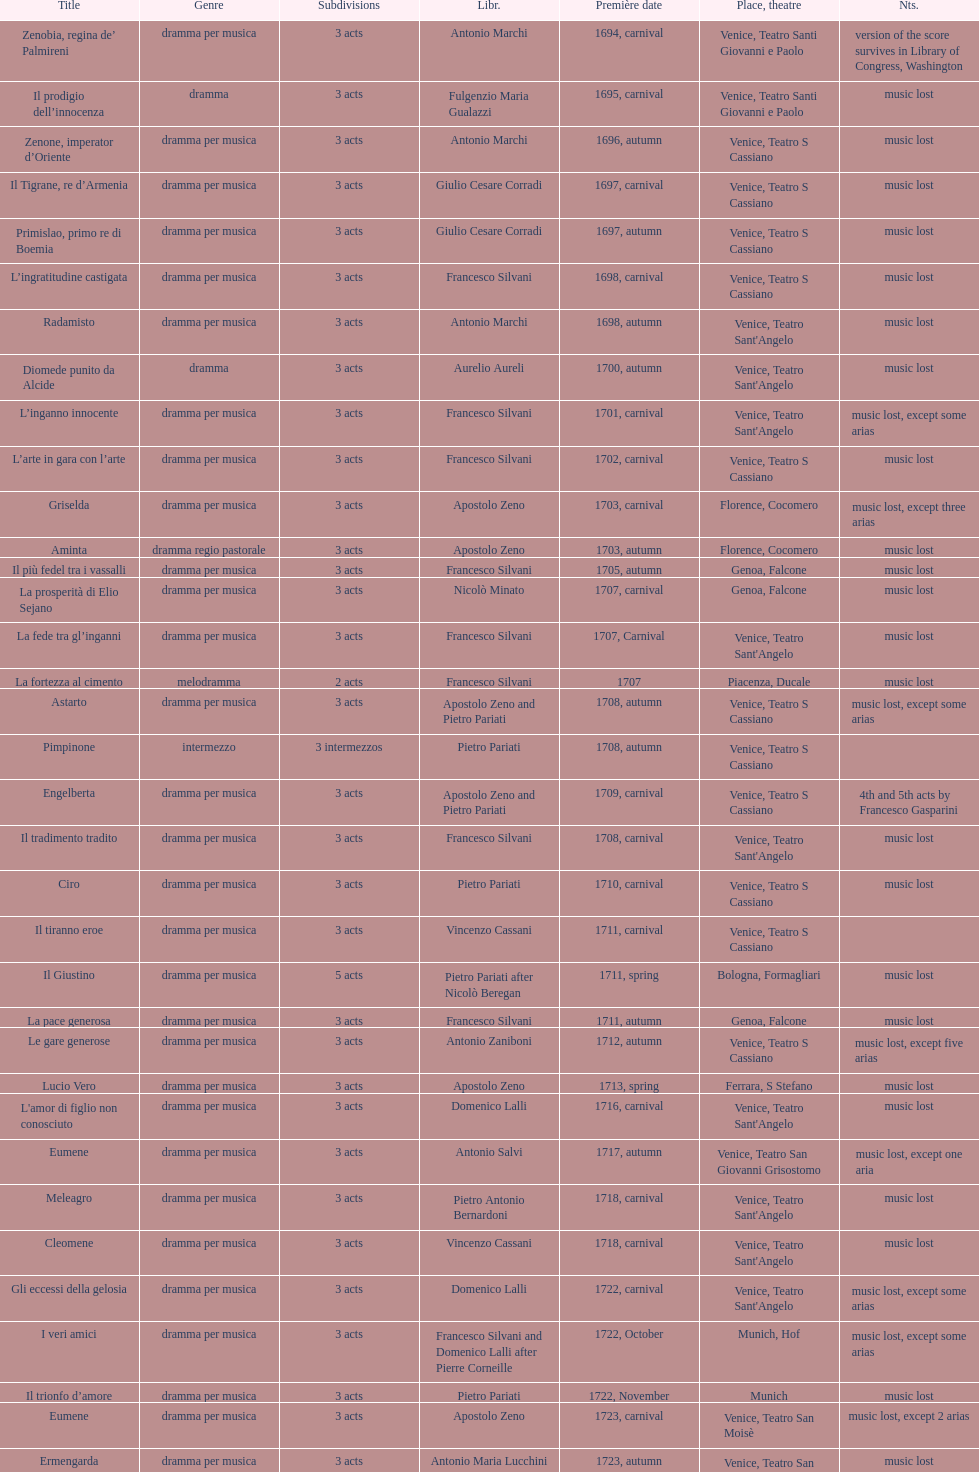Which was released earlier, artamene or merope? Merope. 